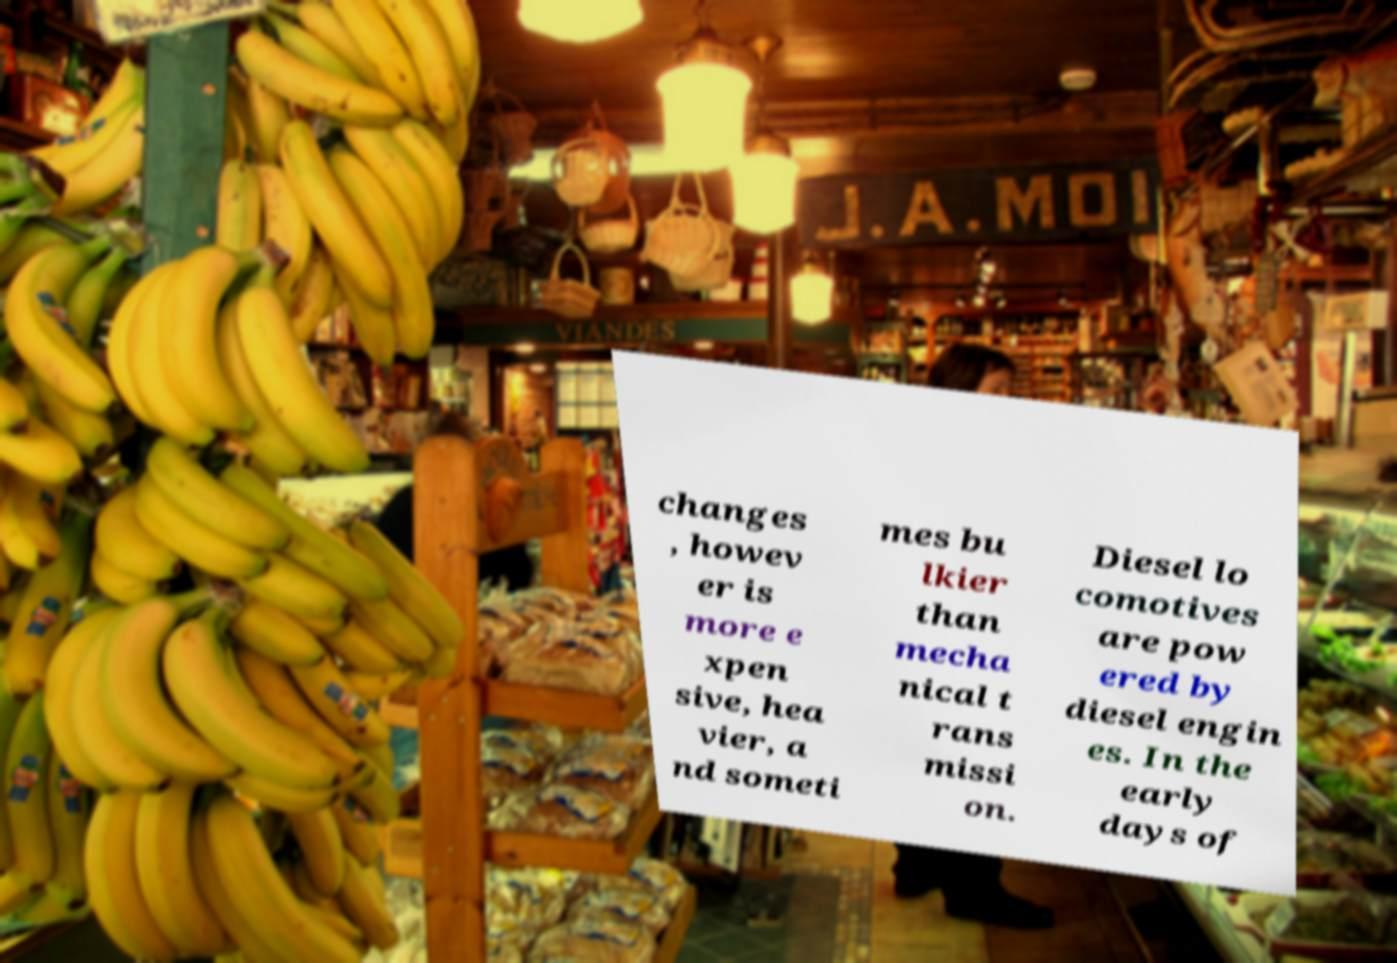I need the written content from this picture converted into text. Can you do that? changes , howev er is more e xpen sive, hea vier, a nd someti mes bu lkier than mecha nical t rans missi on. Diesel lo comotives are pow ered by diesel engin es. In the early days of 